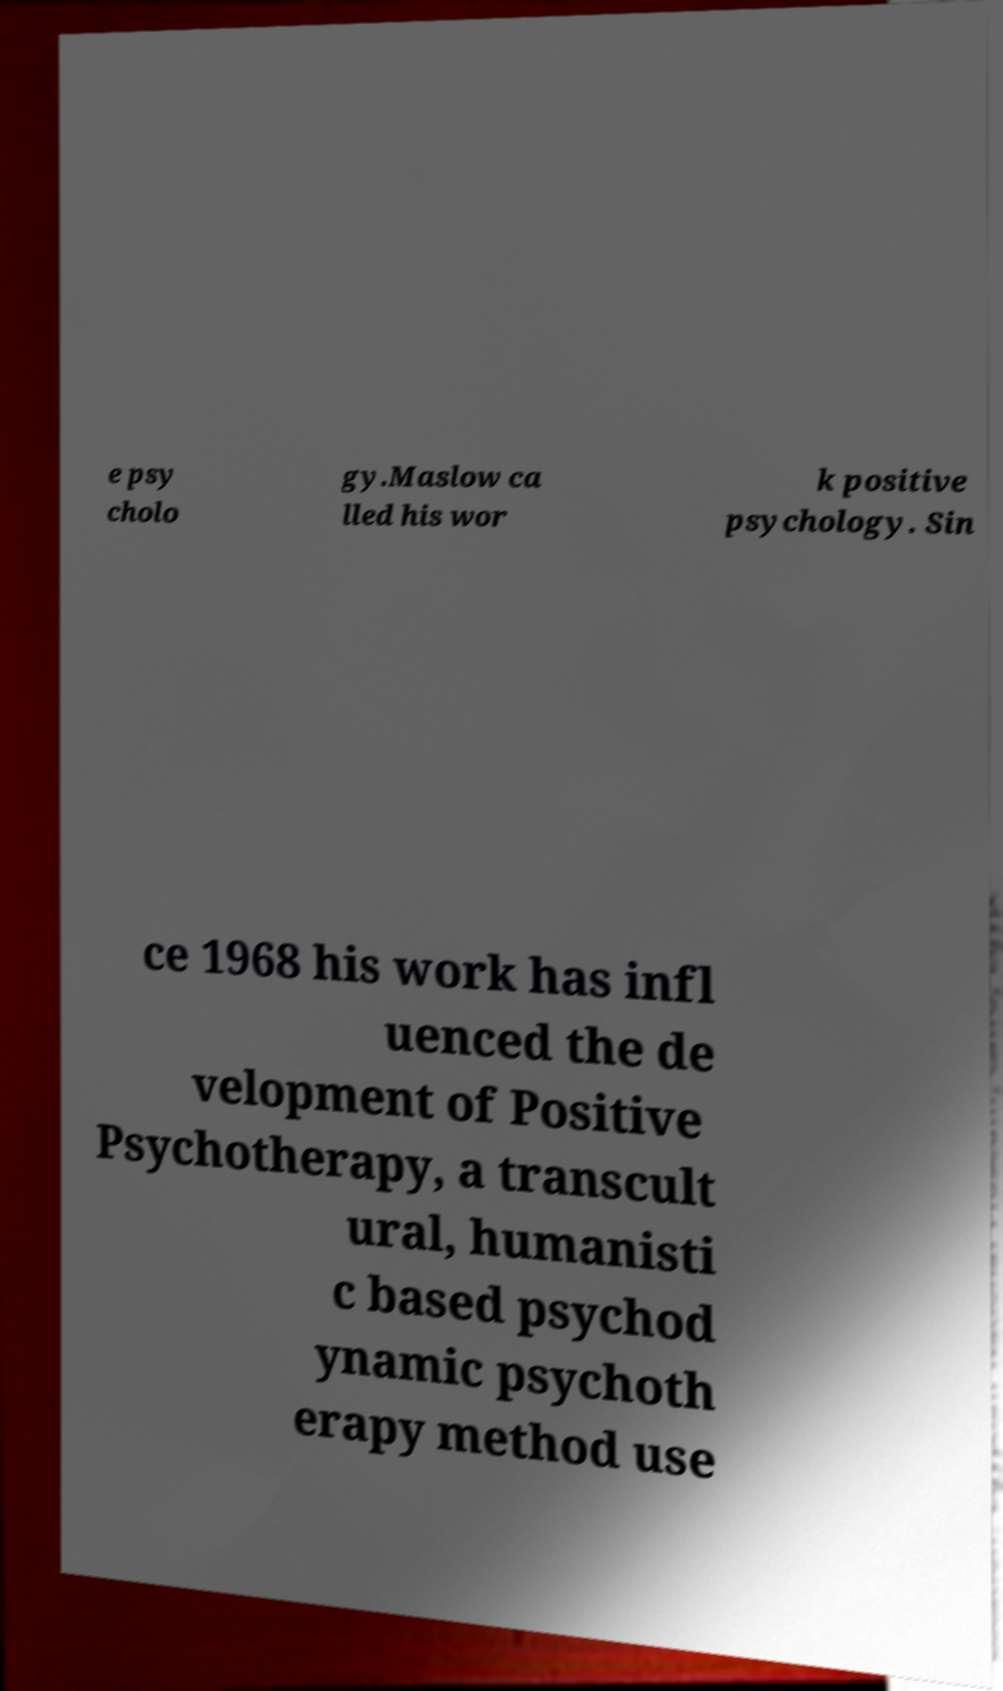I need the written content from this picture converted into text. Can you do that? e psy cholo gy.Maslow ca lled his wor k positive psychology. Sin ce 1968 his work has infl uenced the de velopment of Positive Psychotherapy, a transcult ural, humanisti c based psychod ynamic psychoth erapy method use 